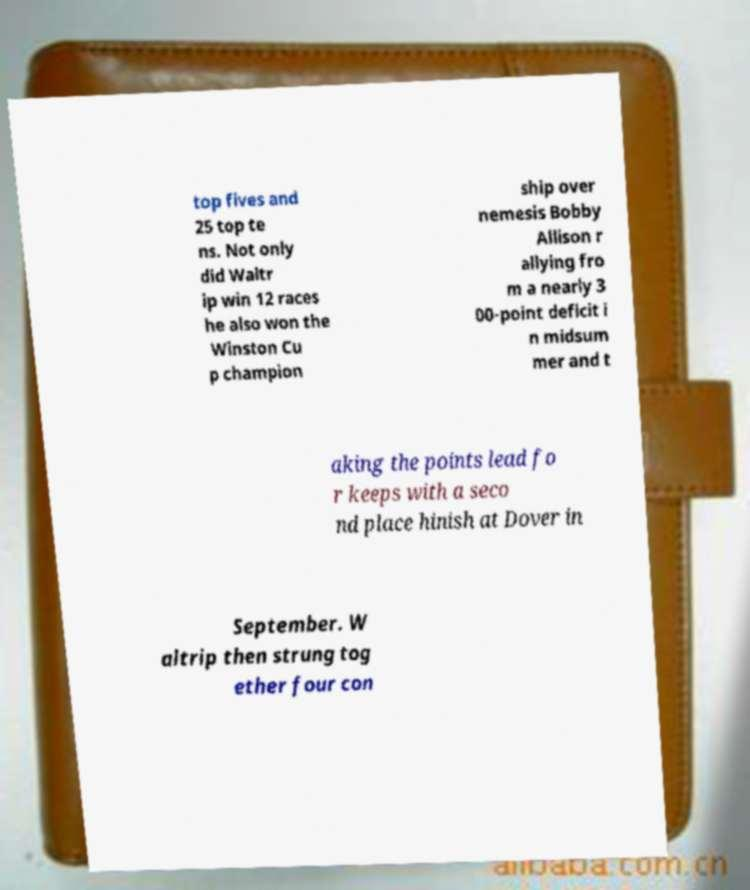Can you accurately transcribe the text from the provided image for me? top fives and 25 top te ns. Not only did Waltr ip win 12 races he also won the Winston Cu p champion ship over nemesis Bobby Allison r allying fro m a nearly 3 00-point deficit i n midsum mer and t aking the points lead fo r keeps with a seco nd place hinish at Dover in September. W altrip then strung tog ether four con 